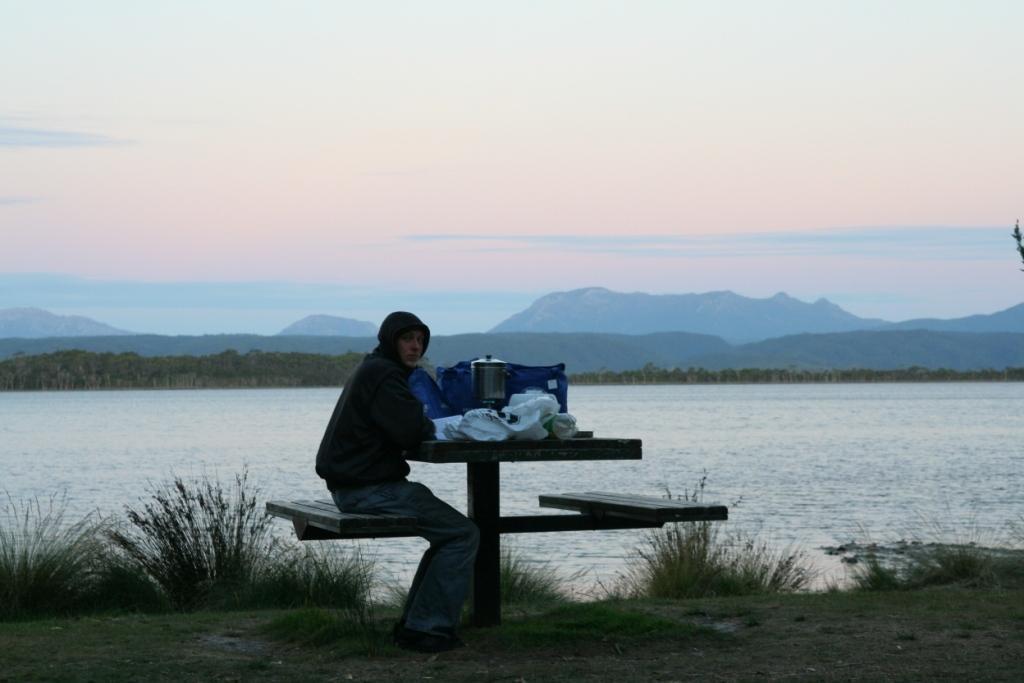Can you describe this image briefly? In this Image I see a person who is sitting on the bench and there is a table in front and there are few things on it and the person is on the grass. In the background I see the water, mountains and the sky. 